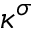Convert formula to latex. <formula><loc_0><loc_0><loc_500><loc_500>\kappa ^ { \sigma }</formula> 